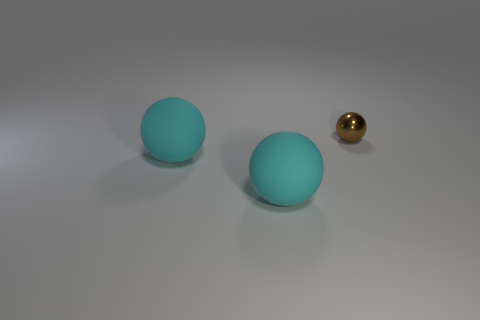What number of matte things are either small spheres or big purple objects?
Offer a terse response. 0. Are there any other things that have the same size as the brown object?
Give a very brief answer. No. What size is the brown shiny object?
Ensure brevity in your answer.  Small. Is the number of metal balls in front of the metal thing less than the number of tiny brown metallic things?
Keep it short and to the point. Yes. Are there any blue metallic objects that have the same shape as the small brown object?
Provide a short and direct response. No. What number of large rubber things are the same shape as the small brown object?
Offer a terse response. 2. Is the number of tiny brown objects less than the number of cyan spheres?
Your response must be concise. Yes. Is the number of brown shiny things greater than the number of large cyan spheres?
Provide a succinct answer. No. How many tiny objects are cyan rubber balls or blue matte spheres?
Ensure brevity in your answer.  0. How many other tiny brown spheres have the same material as the small brown sphere?
Your answer should be very brief. 0. 